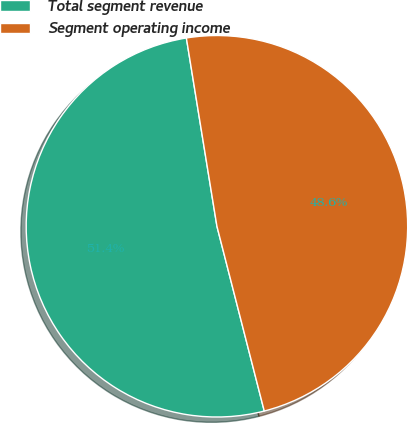<chart> <loc_0><loc_0><loc_500><loc_500><pie_chart><fcel>Total segment revenue<fcel>Segment operating income<nl><fcel>51.43%<fcel>48.57%<nl></chart> 